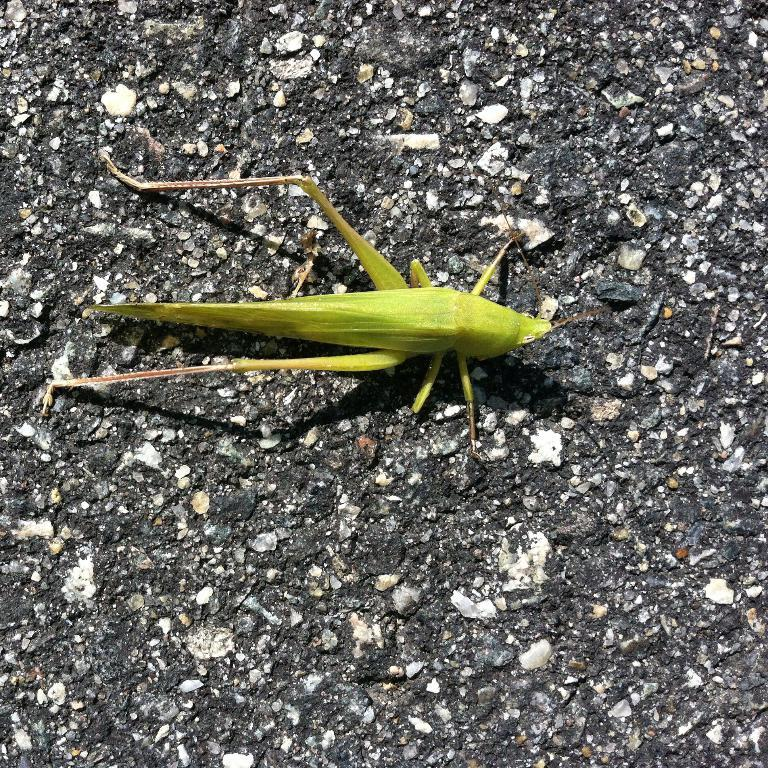What type of creature is present in the image? There is a green insect in the image. Where is the insect located in the image? The insect is on the surface. Is there a volcano erupting in the background of the image? There is no volcano present in the image. What type of tin object can be seen in the image? There is no tin object present in the image. 